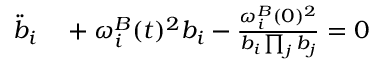<formula> <loc_0><loc_0><loc_500><loc_500>\begin{array} { r l } { \ddot { b } _ { i } } & + { \omega _ { i } ^ { B } } ( t ) ^ { 2 } b _ { i } - \frac { { \omega _ { i } ^ { B } } ( 0 ) ^ { 2 } } { b _ { i } \prod _ { j } b _ { j } } = 0 } \end{array}</formula> 